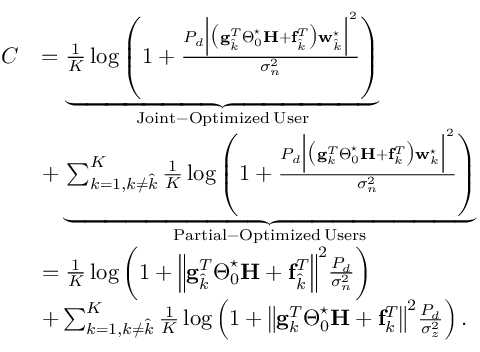Convert formula to latex. <formula><loc_0><loc_0><loc_500><loc_500>\begin{array} { r l } { C } & { = \underbrace { \frac { 1 } { K } \log \left ( 1 + \frac { P _ { d } \left | \left ( g _ { \hat { k } } ^ { T } \Theta _ { 0 } ^ { ^ { * } } H + f _ { \hat { k } } ^ { T } \right ) w _ { \hat { k } } ^ { ^ { * } } \right | ^ { 2 } } { \sigma _ { n } ^ { 2 } } \right ) } _ { J o i n t - O p t i m i z e d \, U s e r } } \\ & { + \underbrace { \sum _ { k = 1 , k \neq \hat { k } } ^ { K } \frac { 1 } { K } \log \left ( 1 + \frac { P _ { d } \left | \left ( g _ { k } ^ { T } \Theta _ { 0 } ^ { ^ { * } } H + f _ { k } ^ { T } \right ) w _ { k } ^ { ^ { * } } \right | ^ { 2 } } { \sigma _ { n } ^ { 2 } } \right ) } _ { P a r t i a l - O p t i m i z e d \, U s e r s } } \\ & { = \frac { 1 } { K } \log \left ( 1 + \left \| g _ { \hat { k } } ^ { T } \Theta _ { 0 } ^ { ^ { * } } H + f _ { \hat { k } } ^ { T } \right \| ^ { 2 } \frac { P _ { d } } { \sigma _ { n } ^ { 2 } } \right ) } \\ & { + \sum _ { k = 1 , k \neq \hat { k } } ^ { K } \frac { 1 } { K } \log \left ( 1 + \left \| g _ { k } ^ { T } \Theta _ { 0 } ^ { ^ { * } } H + f _ { k } ^ { T } \right \| ^ { 2 } \frac { P _ { d } } { \sigma _ { z } ^ { 2 } } \right ) . } \end{array}</formula> 